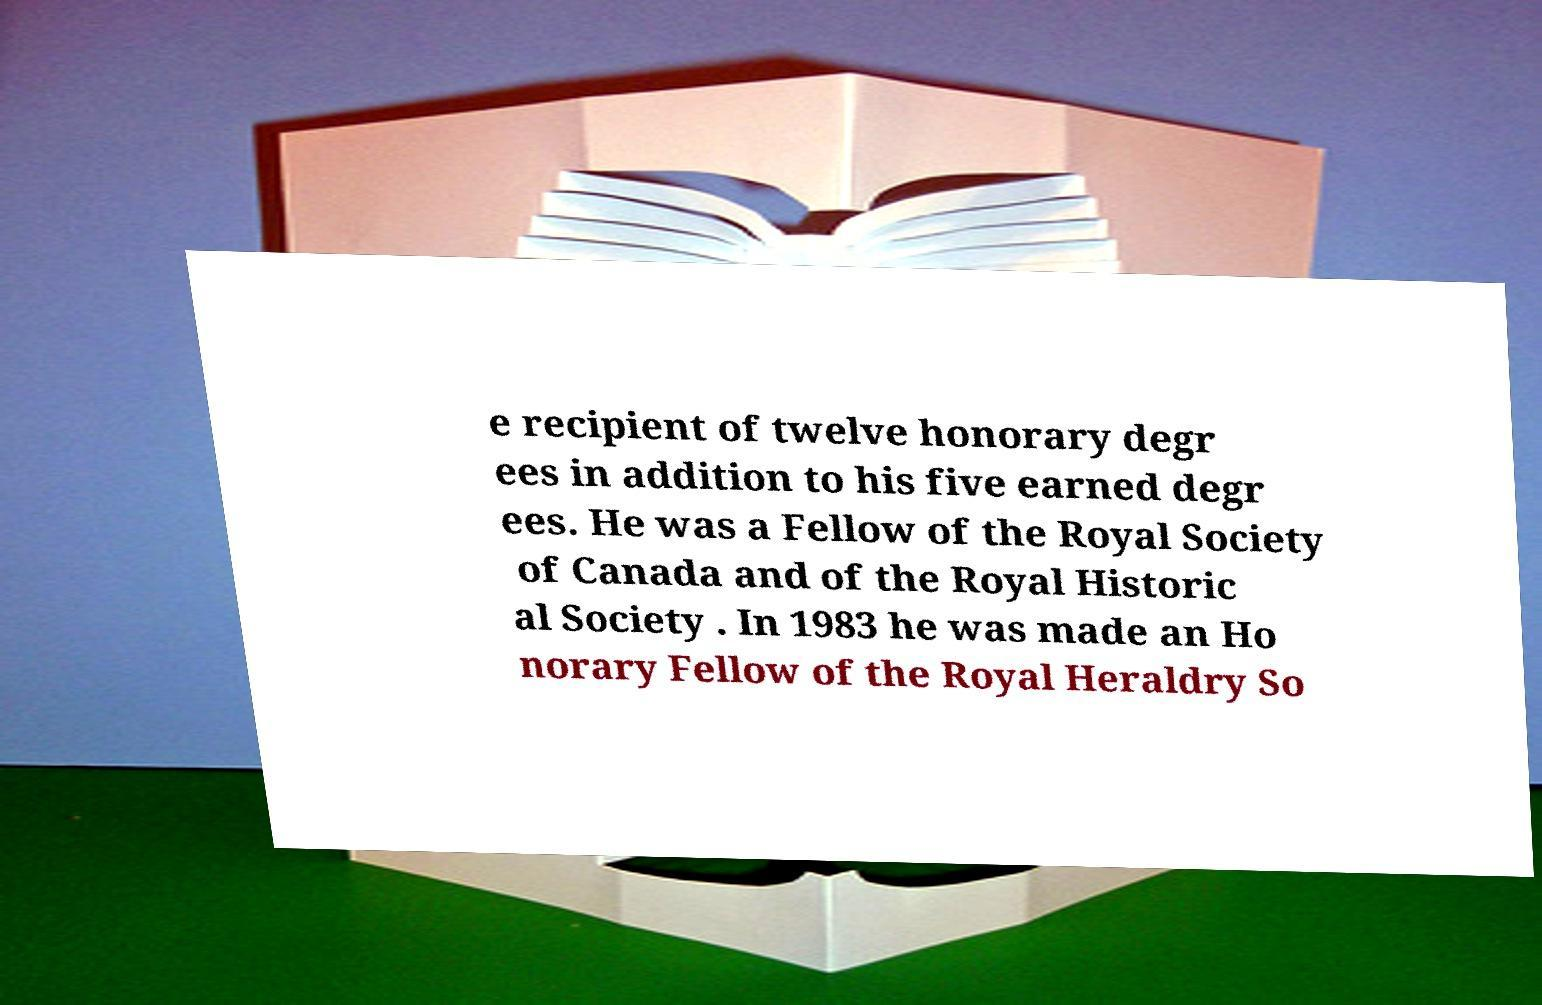Could you assist in decoding the text presented in this image and type it out clearly? e recipient of twelve honorary degr ees in addition to his five earned degr ees. He was a Fellow of the Royal Society of Canada and of the Royal Historic al Society . In 1983 he was made an Ho norary Fellow of the Royal Heraldry So 